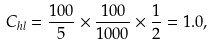Convert formula to latex. <formula><loc_0><loc_0><loc_500><loc_500>C _ { h l } = \frac { 1 0 0 } { 5 } \times \frac { 1 0 0 } { 1 0 0 0 } \times \frac { 1 } { 2 } = 1 . 0 ,</formula> 